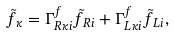Convert formula to latex. <formula><loc_0><loc_0><loc_500><loc_500>\tilde { f } _ { \kappa } = \Gamma ^ { f } _ { R \kappa i } \tilde { f } _ { R i } + \Gamma ^ { f } _ { L \kappa i } \tilde { f } _ { L i } ,</formula> 